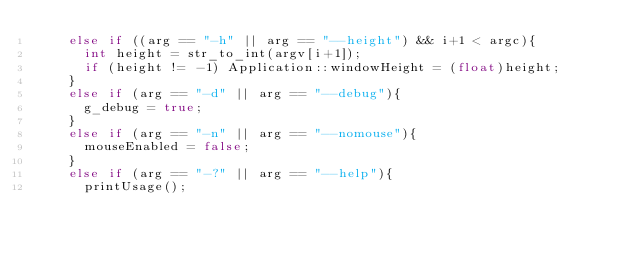<code> <loc_0><loc_0><loc_500><loc_500><_C++_>		else if ((arg == "-h" || arg == "--height") && i+1 < argc){
			int height = str_to_int(argv[i+1]);
			if (height != -1) Application::windowHeight = (float)height;
		}
		else if (arg == "-d" || arg == "--debug"){
			g_debug = true;
		}	
		else if (arg == "-n" || arg == "--nomouse"){
			mouseEnabled = false;
		}
		else if (arg == "-?" || arg == "--help"){
			printUsage();</code> 